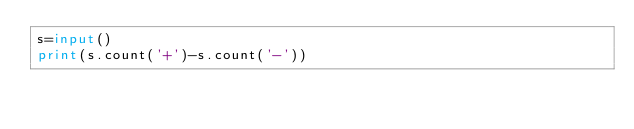<code> <loc_0><loc_0><loc_500><loc_500><_Python_>s=input()
print(s.count('+')-s.count('-'))</code> 